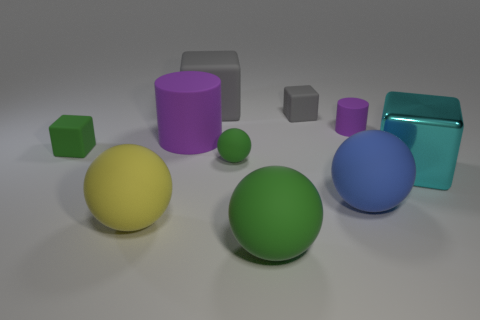There is a green block that is the same material as the tiny purple object; what size is it?
Your answer should be very brief. Small. Is the number of big matte spheres right of the large yellow matte ball greater than the number of blue matte balls?
Provide a succinct answer. Yes. There is a large block right of the small purple cylinder that is behind the green object in front of the cyan cube; what is its material?
Provide a short and direct response. Metal. Is the material of the yellow object the same as the big cylinder to the left of the tiny gray rubber block?
Your answer should be very brief. Yes. What is the material of the other small thing that is the same shape as the tiny gray matte object?
Your answer should be very brief. Rubber. Is there any other thing that is the same material as the large cyan thing?
Ensure brevity in your answer.  No. Are there more rubber cylinders to the right of the large blue matte ball than shiny blocks in front of the large cyan block?
Make the answer very short. Yes. What is the shape of the large blue object that is made of the same material as the small green sphere?
Make the answer very short. Sphere. What number of other objects are there of the same shape as the metallic object?
Keep it short and to the point. 3. The green matte thing left of the large gray rubber thing has what shape?
Your answer should be very brief. Cube. 